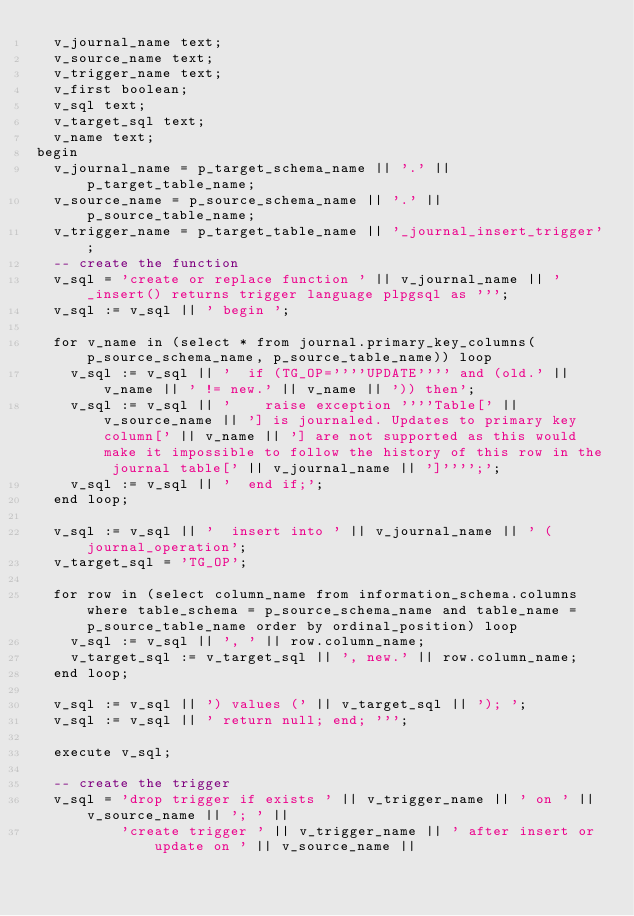<code> <loc_0><loc_0><loc_500><loc_500><_SQL_>  v_journal_name text;
  v_source_name text;
  v_trigger_name text;
  v_first boolean;
  v_sql text;
  v_target_sql text;
  v_name text;
begin
  v_journal_name = p_target_schema_name || '.' || p_target_table_name;
  v_source_name = p_source_schema_name || '.' || p_source_table_name;
  v_trigger_name = p_target_table_name || '_journal_insert_trigger';
  -- create the function
  v_sql = 'create or replace function ' || v_journal_name || '_insert() returns trigger language plpgsql as ''';
  v_sql := v_sql || ' begin ';

  for v_name in (select * from journal.primary_key_columns(p_source_schema_name, p_source_table_name)) loop
    v_sql := v_sql || '  if (TG_OP=''''UPDATE'''' and (old.' || v_name || ' != new.' || v_name || ')) then';
    v_sql := v_sql || '    raise exception ''''Table[' || v_source_name || '] is journaled. Updates to primary key column[' || v_name || '] are not supported as this would make it impossible to follow the history of this row in the journal table[' || v_journal_name || ']'''';';
    v_sql := v_sql || '  end if;';
  end loop;

  v_sql := v_sql || '  insert into ' || v_journal_name || ' (journal_operation';
  v_target_sql = 'TG_OP';

  for row in (select column_name from information_schema.columns where table_schema = p_source_schema_name and table_name = p_source_table_name order by ordinal_position) loop
    v_sql := v_sql || ', ' || row.column_name;
    v_target_sql := v_target_sql || ', new.' || row.column_name;
  end loop;

  v_sql := v_sql || ') values (' || v_target_sql || '); ';
  v_sql := v_sql || ' return null; end; ''';

  execute v_sql;

  -- create the trigger
  v_sql = 'drop trigger if exists ' || v_trigger_name || ' on ' || v_source_name || '; ' ||
          'create trigger ' || v_trigger_name || ' after insert or update on ' || v_source_name ||</code> 